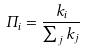Convert formula to latex. <formula><loc_0><loc_0><loc_500><loc_500>\Pi _ { i } = \frac { k _ { i } } { \sum _ { j } k _ { j } }</formula> 